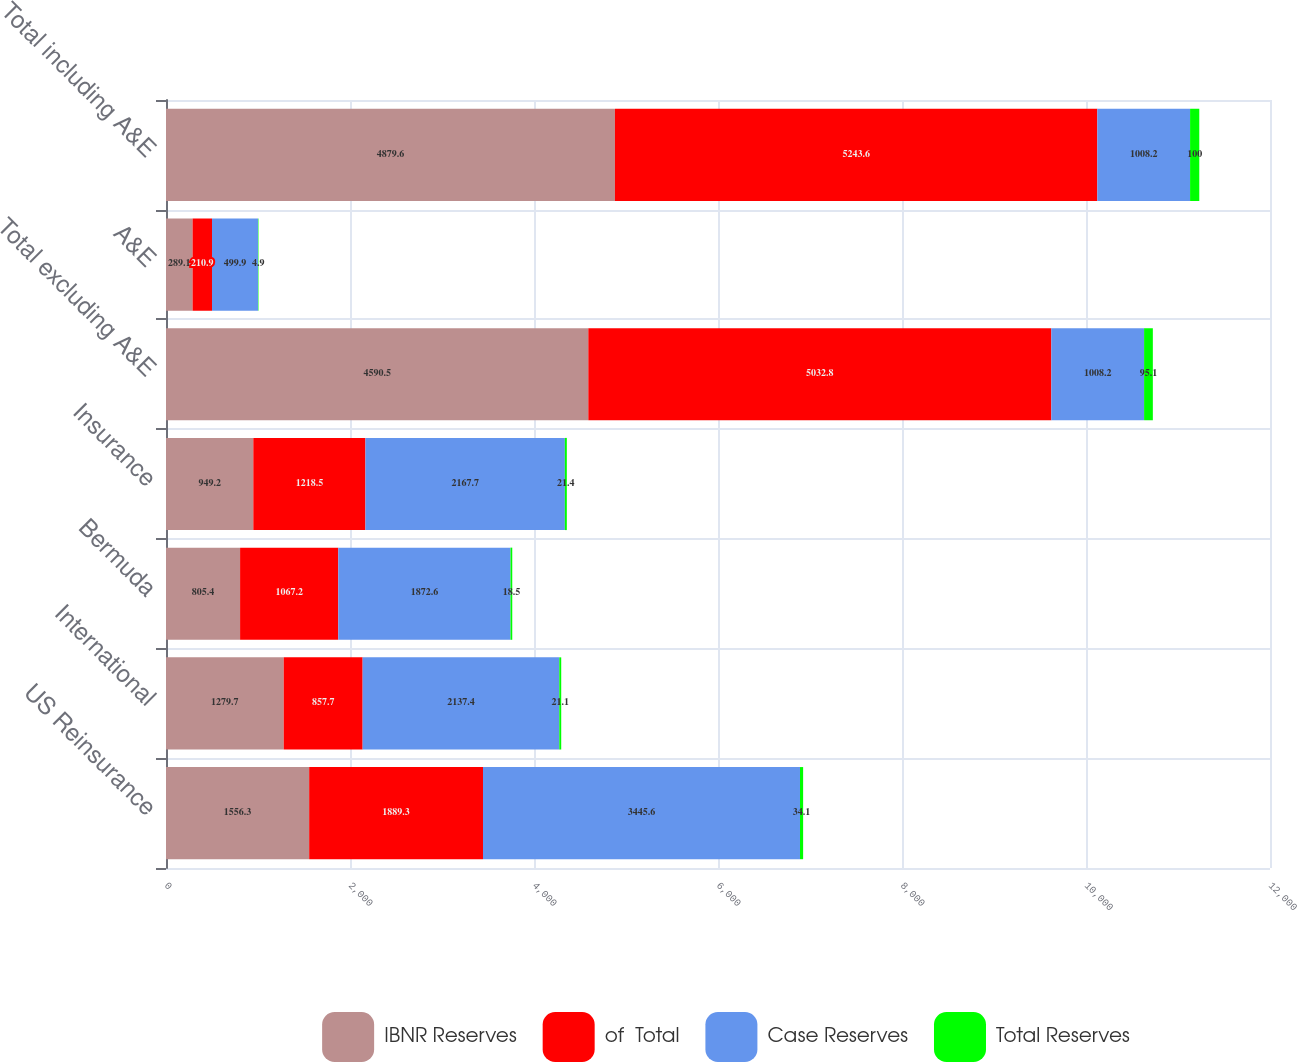Convert chart to OTSL. <chart><loc_0><loc_0><loc_500><loc_500><stacked_bar_chart><ecel><fcel>US Reinsurance<fcel>International<fcel>Bermuda<fcel>Insurance<fcel>Total excluding A&E<fcel>A&E<fcel>Total including A&E<nl><fcel>IBNR Reserves<fcel>1556.3<fcel>1279.7<fcel>805.4<fcel>949.2<fcel>4590.5<fcel>289.1<fcel>4879.6<nl><fcel>of  Total<fcel>1889.3<fcel>857.7<fcel>1067.2<fcel>1218.5<fcel>5032.8<fcel>210.9<fcel>5243.6<nl><fcel>Case Reserves<fcel>3445.6<fcel>2137.4<fcel>1872.6<fcel>2167.7<fcel>1008.2<fcel>499.9<fcel>1008.2<nl><fcel>Total Reserves<fcel>34.1<fcel>21.1<fcel>18.5<fcel>21.4<fcel>95.1<fcel>4.9<fcel>100<nl></chart> 